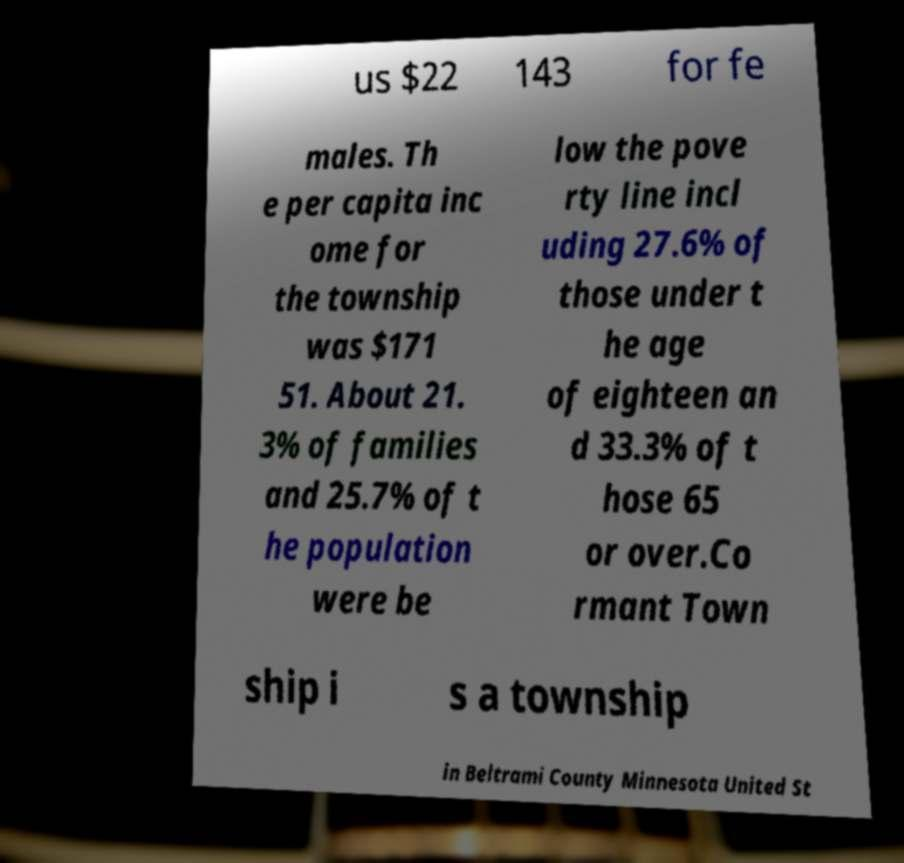Can you accurately transcribe the text from the provided image for me? us $22 143 for fe males. Th e per capita inc ome for the township was $171 51. About 21. 3% of families and 25.7% of t he population were be low the pove rty line incl uding 27.6% of those under t he age of eighteen an d 33.3% of t hose 65 or over.Co rmant Town ship i s a township in Beltrami County Minnesota United St 